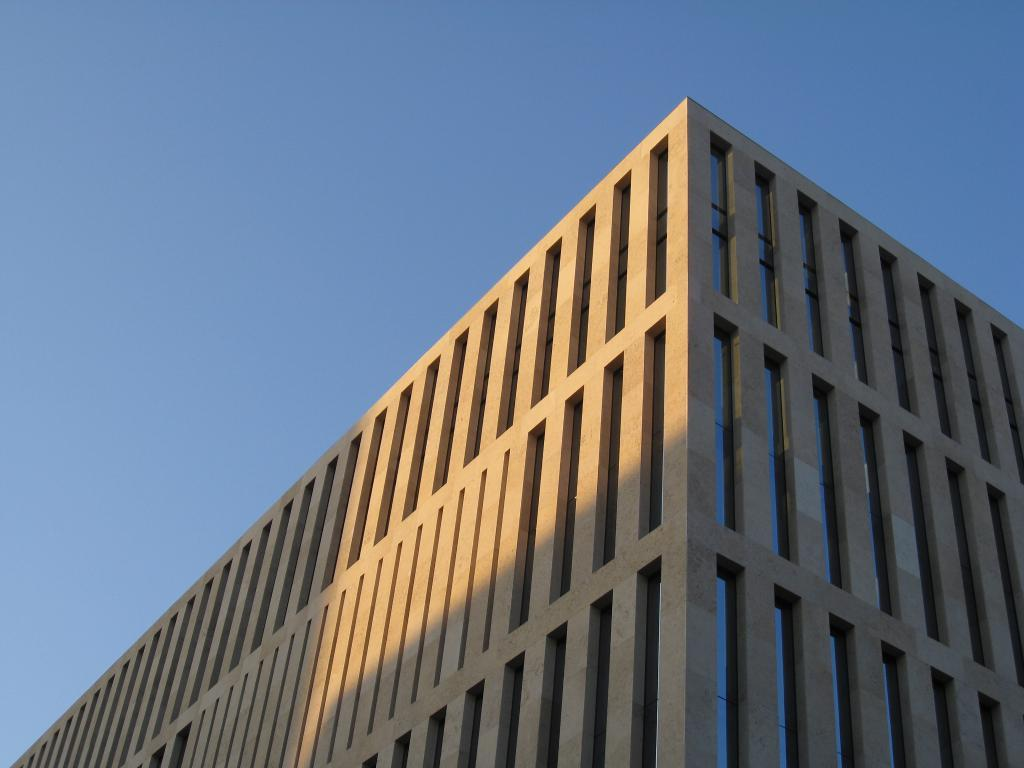What type of structure is in the image? There is a building in the image. What color is the building? The building is cream in color. Are there any architectural features near the building? Yes, there are pillars near the building. What can be seen on the ground near the building? There are lines on the ground and glasses on the ground near the building. What is visible in the background of the image? The sky is visible in the background of the image. How many planes are flying over the building in the image? There are no planes visible in the image; it only shows a building, pillars, lines on the ground, glasses, and the sky in the background. What type of fowl can be seen near the building in the image? There are no fowl present in the image; it only shows a building, pillars, lines on the ground, glasses, and the sky in the background. 